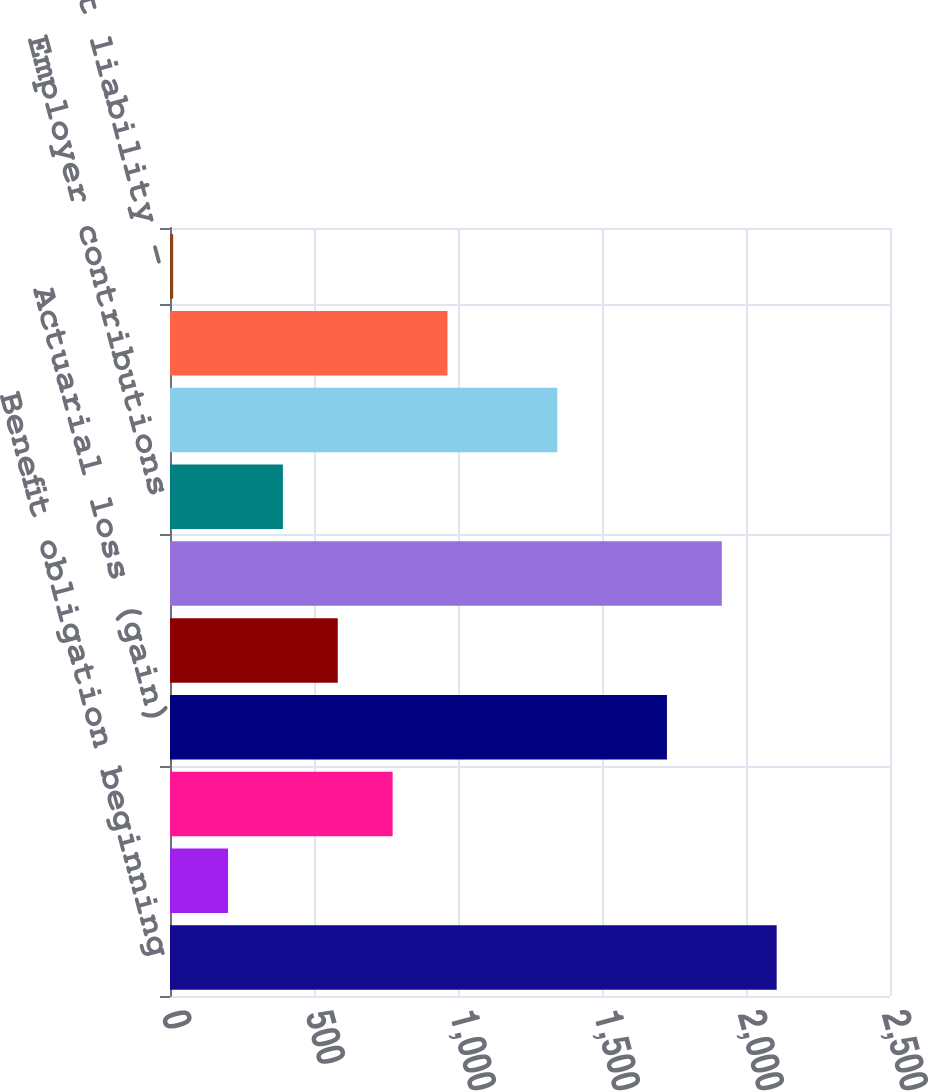Convert chart. <chart><loc_0><loc_0><loc_500><loc_500><bar_chart><fcel>Benefit obligation beginning<fcel>Service cost<fcel>Interest cost<fcel>Actuarial loss (gain)<fcel>Benefits paid<fcel>Benefit obligation ending<fcel>Employer contributions<fcel>Funded status<fcel>Pension liability recognized<fcel>Accrued benefit liability -<nl><fcel>2106.5<fcel>201.5<fcel>773<fcel>1725.5<fcel>582.5<fcel>1916<fcel>392<fcel>1344.5<fcel>963.5<fcel>11<nl></chart> 